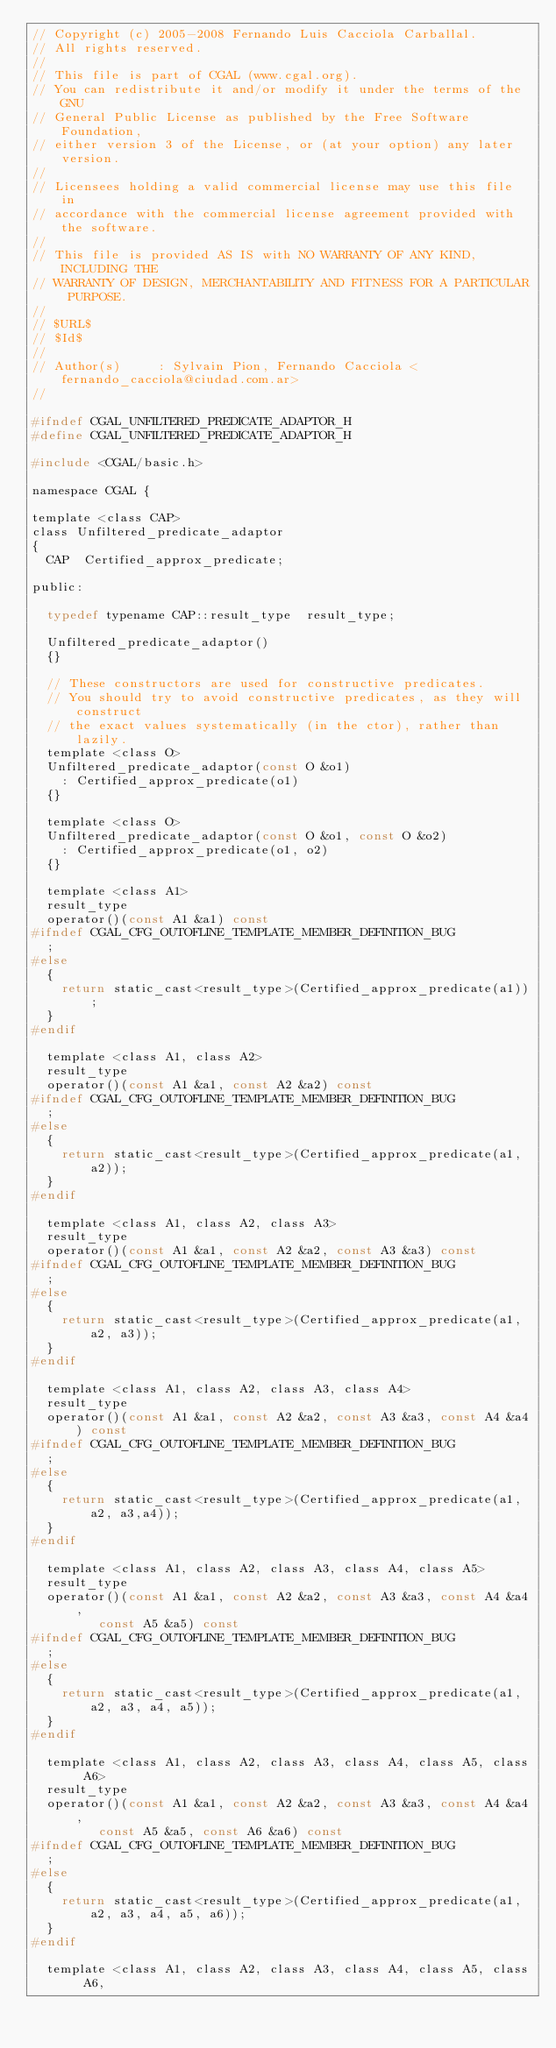Convert code to text. <code><loc_0><loc_0><loc_500><loc_500><_C_>// Copyright (c) 2005-2008 Fernando Luis Cacciola Carballal.
// All rights reserved. 
//
// This file is part of CGAL (www.cgal.org).
// You can redistribute it and/or modify it under the terms of the GNU
// General Public License as published by the Free Software Foundation,
// either version 3 of the License, or (at your option) any later version.
//
// Licensees holding a valid commercial license may use this file in
// accordance with the commercial license agreement provided with the software.
//
// This file is provided AS IS with NO WARRANTY OF ANY KIND, INCLUDING THE
// WARRANTY OF DESIGN, MERCHANTABILITY AND FITNESS FOR A PARTICULAR PURPOSE.
//
// $URL$
// $Id$
// 
// Author(s)     : Sylvain Pion, Fernando Cacciola <fernando_cacciola@ciudad.com.ar>
//

#ifndef CGAL_UNFILTERED_PREDICATE_ADAPTOR_H
#define CGAL_UNFILTERED_PREDICATE_ADAPTOR_H

#include <CGAL/basic.h>

namespace CGAL {

template <class CAP>
class Unfiltered_predicate_adaptor
{
  CAP  Certified_approx_predicate;

public:

  typedef typename CAP::result_type  result_type;

  Unfiltered_predicate_adaptor()
  {}

  // These constructors are used for constructive predicates.
  // You should try to avoid constructive predicates, as they will construct
  // the exact values systematically (in the ctor), rather than lazily.
  template <class O>
  Unfiltered_predicate_adaptor(const O &o1)
    : Certified_approx_predicate(o1)
  {}

  template <class O>
  Unfiltered_predicate_adaptor(const O &o1, const O &o2)
    : Certified_approx_predicate(o1, o2)
  {}

  template <class A1>
  result_type
  operator()(const A1 &a1) const
#ifndef CGAL_CFG_OUTOFLINE_TEMPLATE_MEMBER_DEFINITION_BUG
  ;
#else
  {
    return static_cast<result_type>(Certified_approx_predicate(a1));
  }
#endif

  template <class A1, class A2>
  result_type
  operator()(const A1 &a1, const A2 &a2) const
#ifndef CGAL_CFG_OUTOFLINE_TEMPLATE_MEMBER_DEFINITION_BUG
  ;
#else
  {
    return static_cast<result_type>(Certified_approx_predicate(a1, a2));
  }
#endif

  template <class A1, class A2, class A3>
  result_type
  operator()(const A1 &a1, const A2 &a2, const A3 &a3) const
#ifndef CGAL_CFG_OUTOFLINE_TEMPLATE_MEMBER_DEFINITION_BUG
  ;
#else
  {
    return static_cast<result_type>(Certified_approx_predicate(a1, a2, a3));
  }
#endif

  template <class A1, class A2, class A3, class A4>
  result_type
  operator()(const A1 &a1, const A2 &a2, const A3 &a3, const A4 &a4) const
#ifndef CGAL_CFG_OUTOFLINE_TEMPLATE_MEMBER_DEFINITION_BUG
  ;
#else
  {
    return static_cast<result_type>(Certified_approx_predicate(a1, a2, a3,a4));
  }
#endif

  template <class A1, class A2, class A3, class A4, class A5>
  result_type
  operator()(const A1 &a1, const A2 &a2, const A3 &a3, const A4 &a4,
	     const A5 &a5) const
#ifndef CGAL_CFG_OUTOFLINE_TEMPLATE_MEMBER_DEFINITION_BUG
  ;
#else
  {
    return static_cast<result_type>(Certified_approx_predicate(a1, a2, a3, a4, a5));
  }
#endif

  template <class A1, class A2, class A3, class A4, class A5, class A6>
  result_type
  operator()(const A1 &a1, const A2 &a2, const A3 &a3, const A4 &a4,
	     const A5 &a5, const A6 &a6) const
#ifndef CGAL_CFG_OUTOFLINE_TEMPLATE_MEMBER_DEFINITION_BUG
  ;
#else
  {
    return static_cast<result_type>(Certified_approx_predicate(a1, a2, a3, a4, a5, a6));
  }
#endif

  template <class A1, class A2, class A3, class A4, class A5, class A6,</code> 